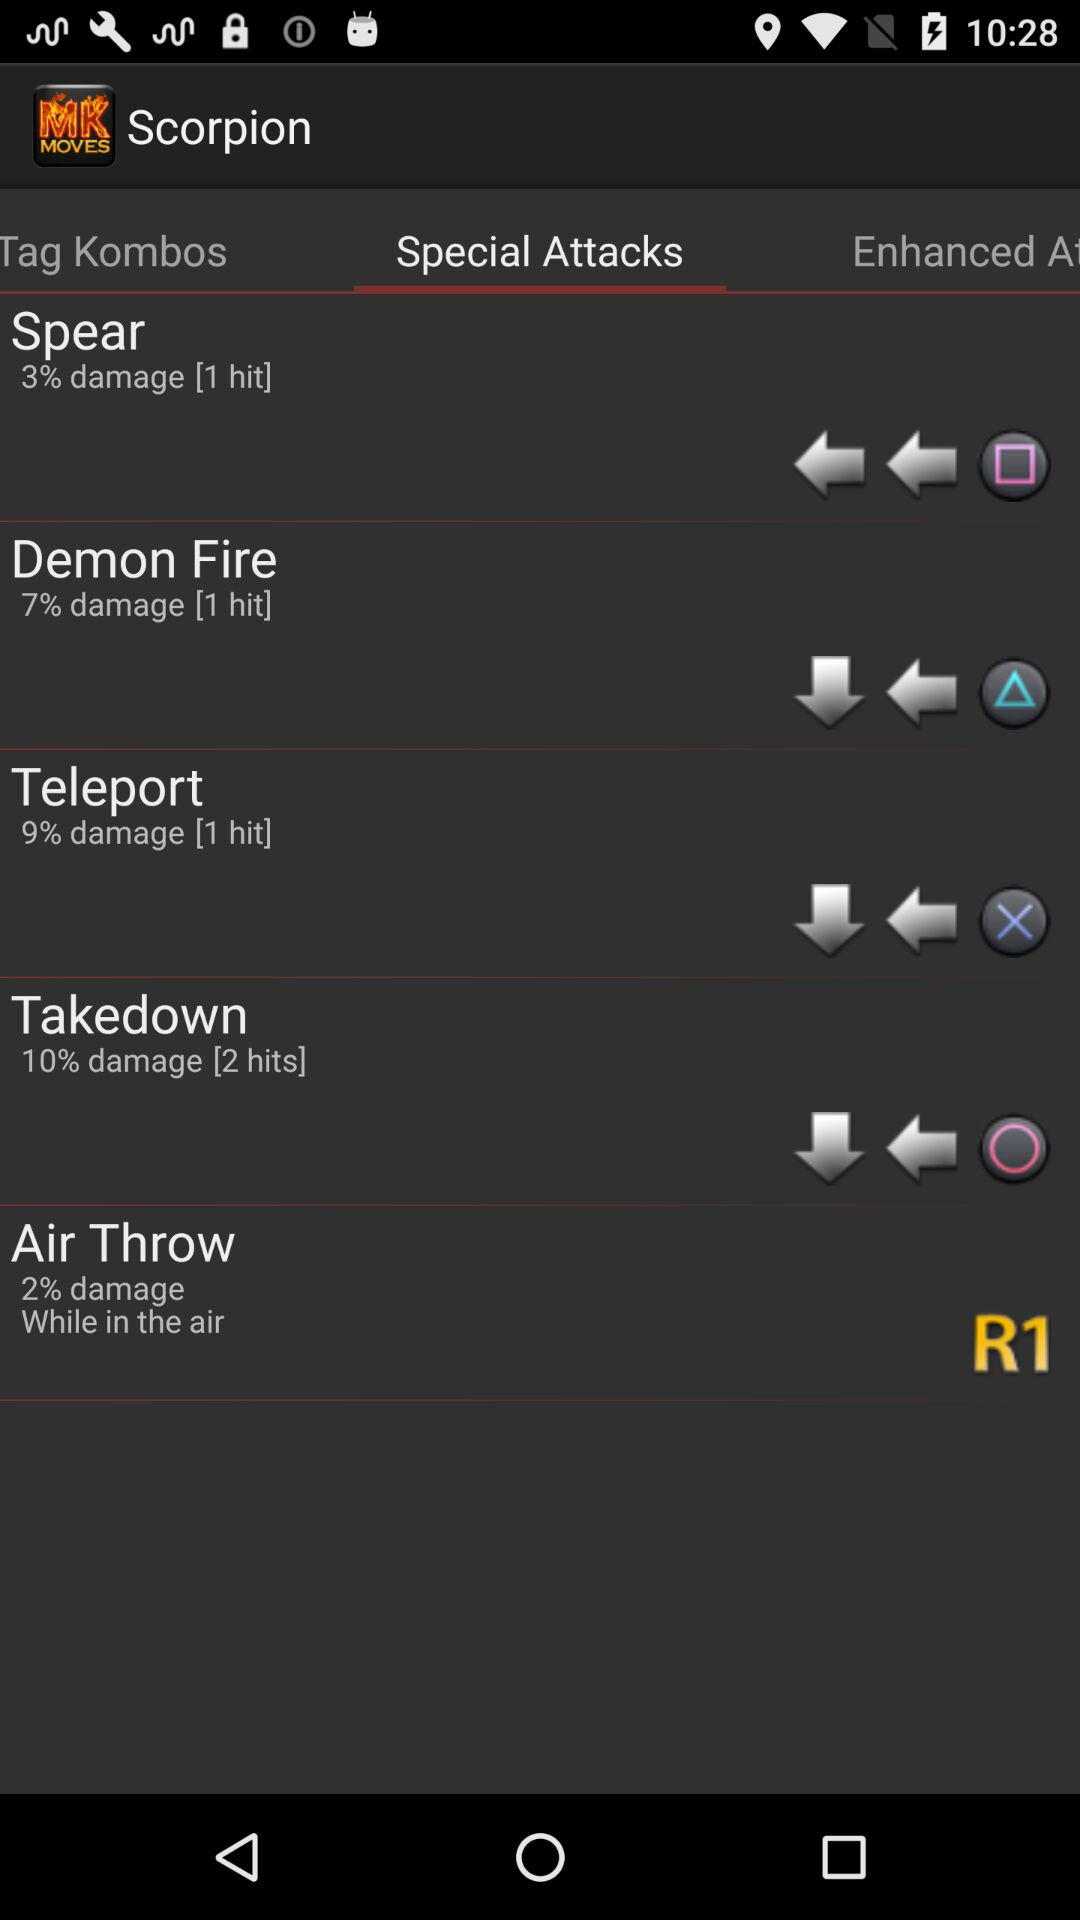How much damage does "Spear" inflect? "Spear" inflicts 3% damage. 